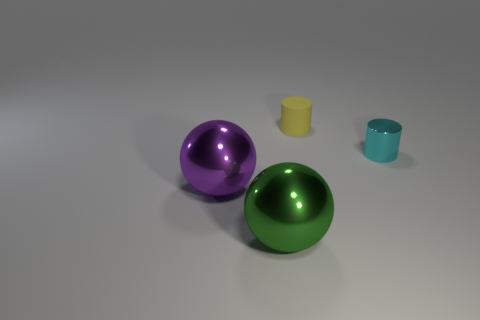Add 2 blue cylinders. How many objects exist? 6 Add 1 tiny yellow rubber objects. How many tiny yellow rubber objects are left? 2 Add 1 cyan metal things. How many cyan metal things exist? 2 Subtract 0 blue spheres. How many objects are left? 4 Subtract all rubber objects. Subtract all purple cylinders. How many objects are left? 3 